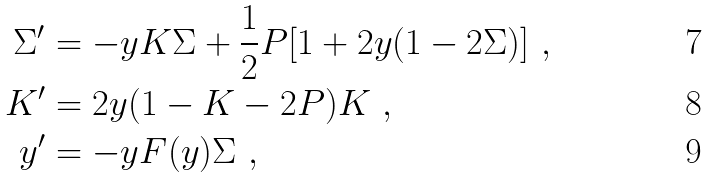Convert formula to latex. <formula><loc_0><loc_0><loc_500><loc_500>\Sigma ^ { \prime } & = - y K \Sigma + \frac { 1 } { 2 } P [ 1 + 2 y ( 1 - 2 \Sigma ) ] \ , \\ K ^ { \prime } & = 2 y ( 1 - K - 2 P ) K \ , \\ y ^ { \prime } & = - y F ( y ) \Sigma \ ,</formula> 